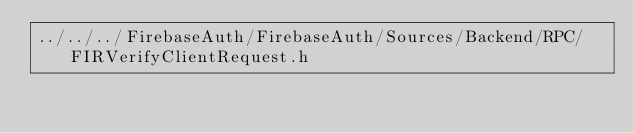<code> <loc_0><loc_0><loc_500><loc_500><_C_>../../../FirebaseAuth/FirebaseAuth/Sources/Backend/RPC/FIRVerifyClientRequest.h</code> 